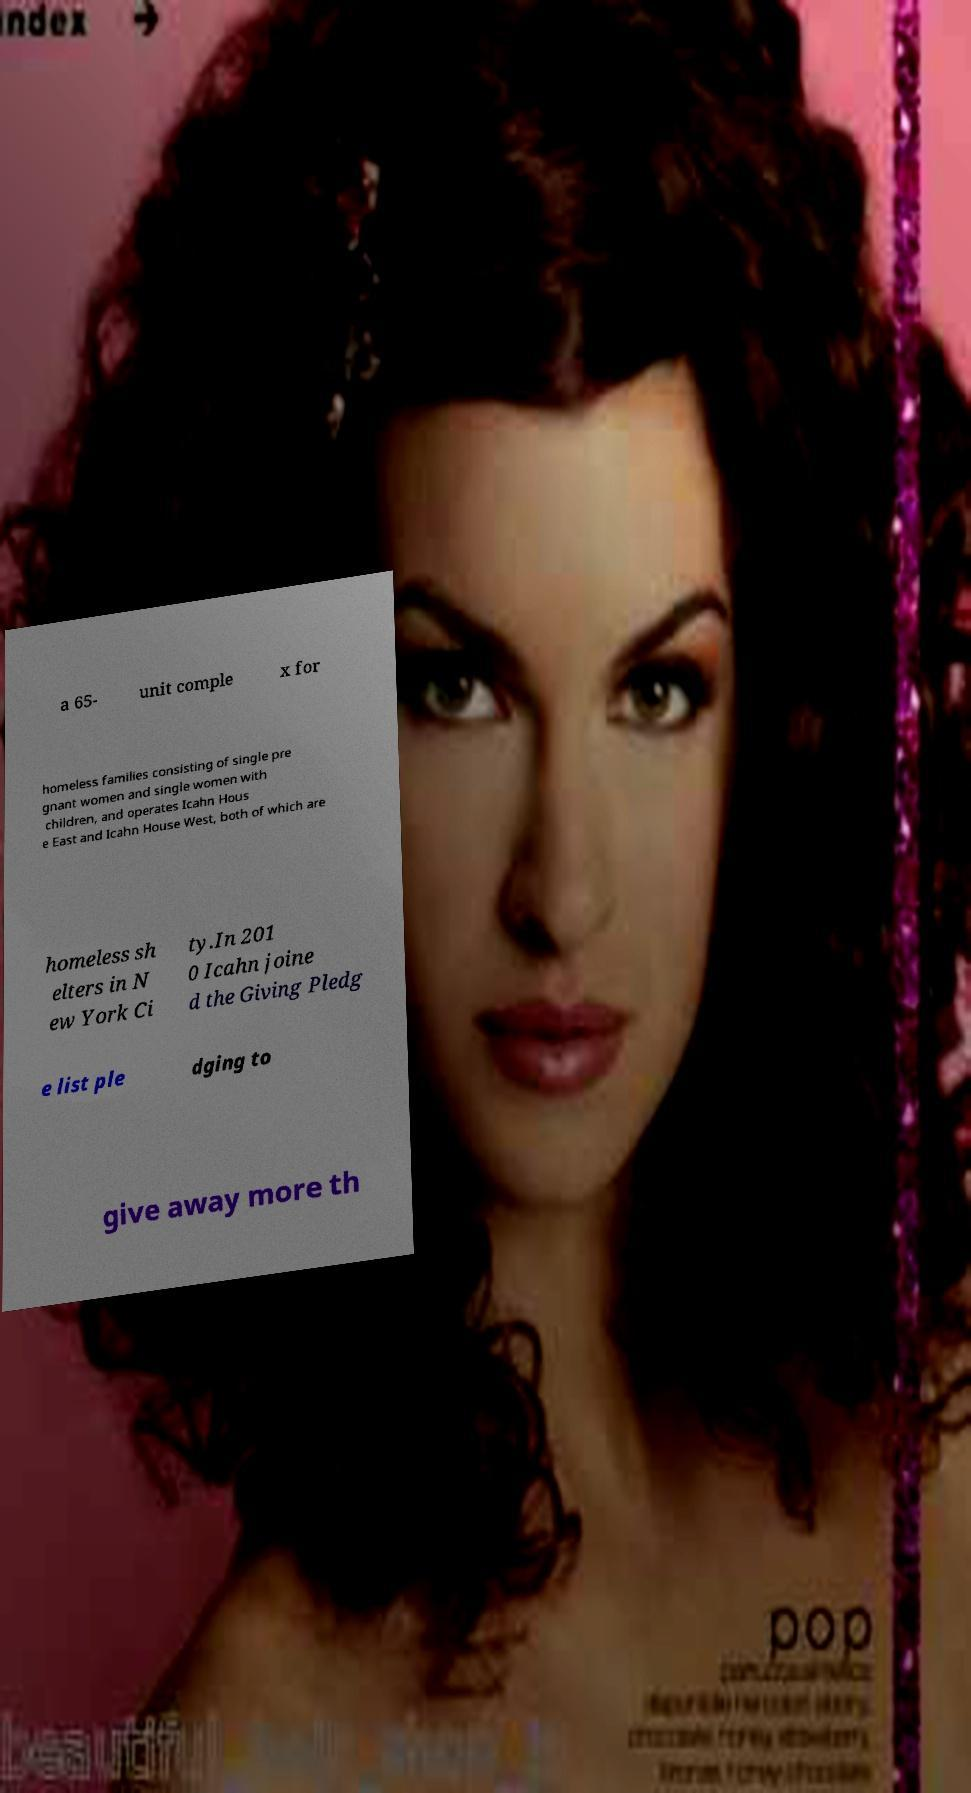Could you extract and type out the text from this image? a 65- unit comple x for homeless families consisting of single pre gnant women and single women with children, and operates Icahn Hous e East and Icahn House West, both of which are homeless sh elters in N ew York Ci ty.In 201 0 Icahn joine d the Giving Pledg e list ple dging to give away more th 